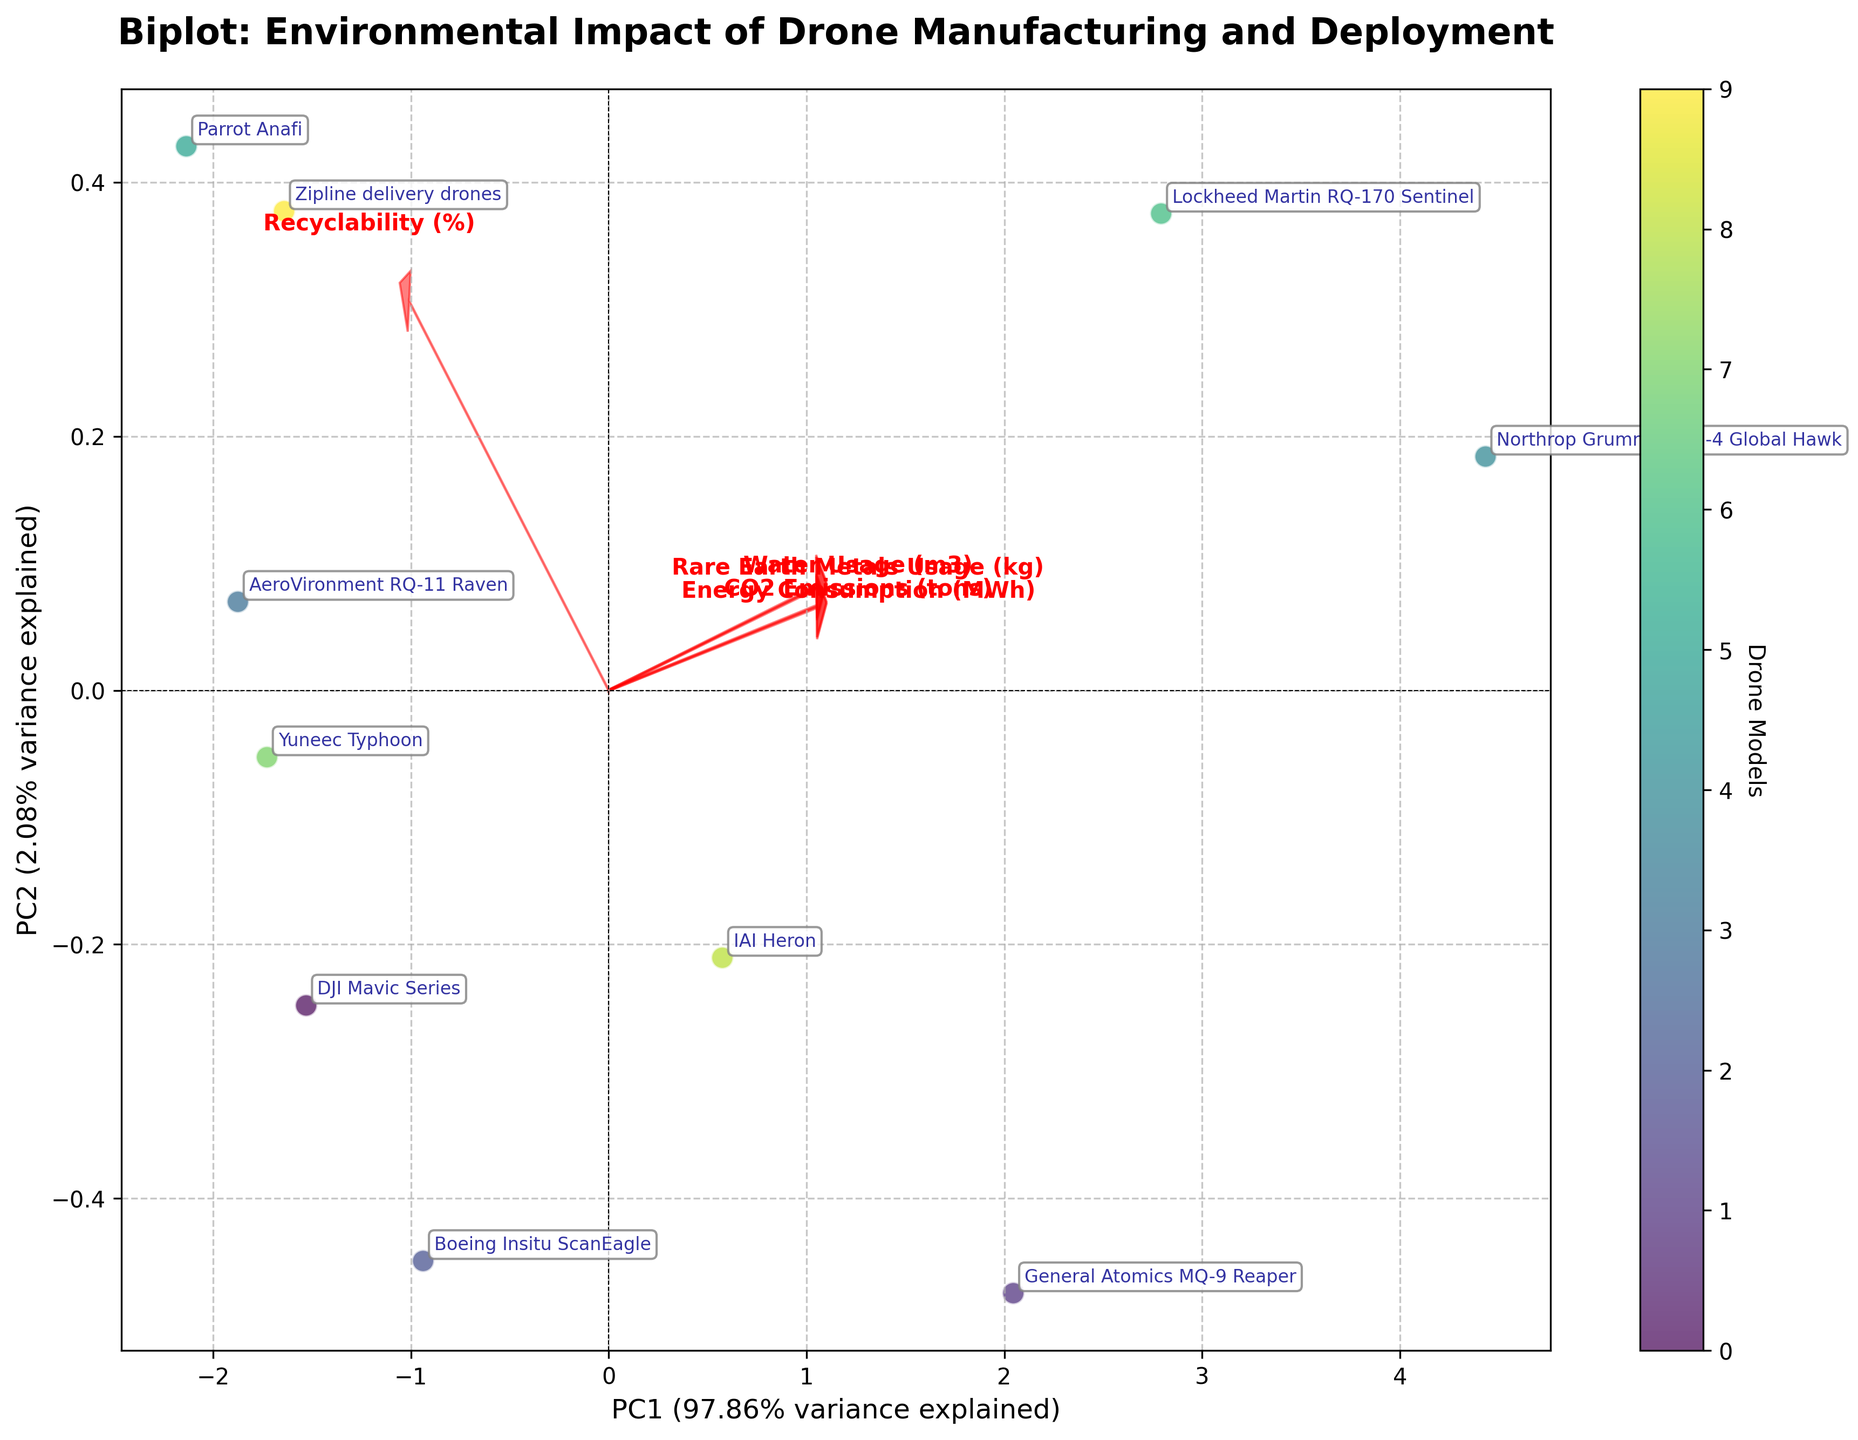what is the title of the figure? The title is typically found at the top of the figure and provides a summary of what the figure represents. In this figure, the title is "Biplot: Environmental Impact of Drone Manufacturing and Deployment".
Answer: Biplot: Environmental Impact of Drone Manufacturing and Deployment how many data points are represented in the figure? The figure shows one point for each drone model listed in the data. Count each labeled point in the scatter plot.
Answer: 10 which drone model has the highest PC1 value? By looking at the plot, identify the point farthest to the right along the x-axis, and find its corresponding label.
Answer: Northrop Grumman RQ-4 Global Hawk what percentage of variance is explained by PC1 and PC2 combined? The percentage of variance explained by PC1 and PC2 is labeled on the x and y axes, respectively. Add these two percentages together.
Answer: ~95.51% which features have the longest arrows, indicating the strongest influence on the plot? The length of the arrows correlates with the magnitude of the eigenvectors. Longer arrows on the biplot indicate stronger influence. Look for the longest red arrows.
Answer: CO2 Emissions and Water Usage are drone models with higher recyclability clustered or scattered in the plot? Higher recyclability percentages correspond to drone models more on the right side of the x-axis. Observe whether these points are grouped together or spread out.
Answer: Clustered what drone model corresponds to the point closest to the origin (0,0) in the biplot? Locate the point closest to the (0,0) coordinates on the plot and identify the associated label.
Answer: DJI Mavic Series what is the correlation between "Energy Consumption" and "CO2 Emissions" based on the direction of the arrows? If the arrows for "Energy Consumption" and "CO2 Emissions" point in similar directions, they are highly correlated. Examine the directions of these arrows on the plot.
Answer: Highly correlated which drone model has the most significant environmental impact in terms of "Rare Earth Metals Usage" based on the PCA plot? Identify which data point is farthest in the direction of the "Rare Earth Metals Usage" arrow from the origin.
Answer: Northrop Grumman RQ-4 Global Hawk which drone model is most environmentally friendly in terms of resource consumption and emissions based on the biplot location? The most environmentally friendly drone would likely be positioned closest to the origin and away from the directions of resource-heavy features. Find the model closest to the origin and not in the direction of heavy feature arrows.
Answer: Parrot Anafi 